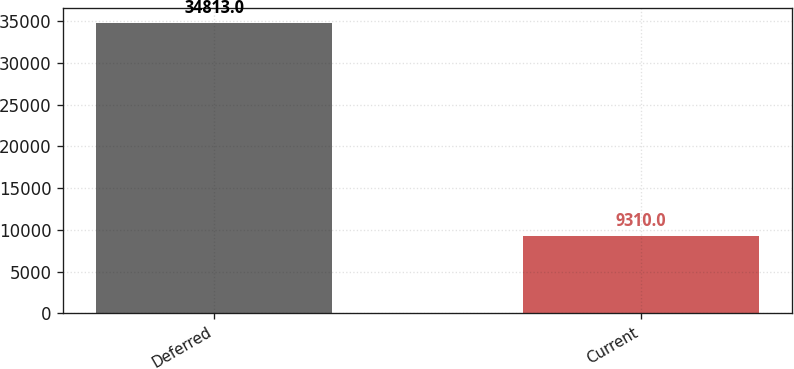<chart> <loc_0><loc_0><loc_500><loc_500><bar_chart><fcel>Deferred<fcel>Current<nl><fcel>34813<fcel>9310<nl></chart> 